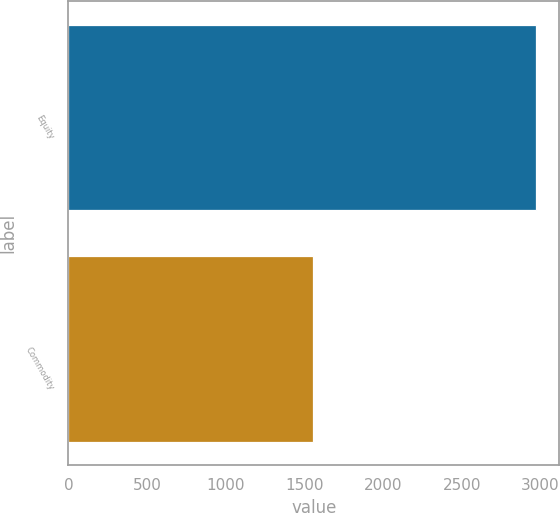Convert chart to OTSL. <chart><loc_0><loc_0><loc_500><loc_500><bar_chart><fcel>Equity<fcel>Commodity<nl><fcel>2972<fcel>1555<nl></chart> 